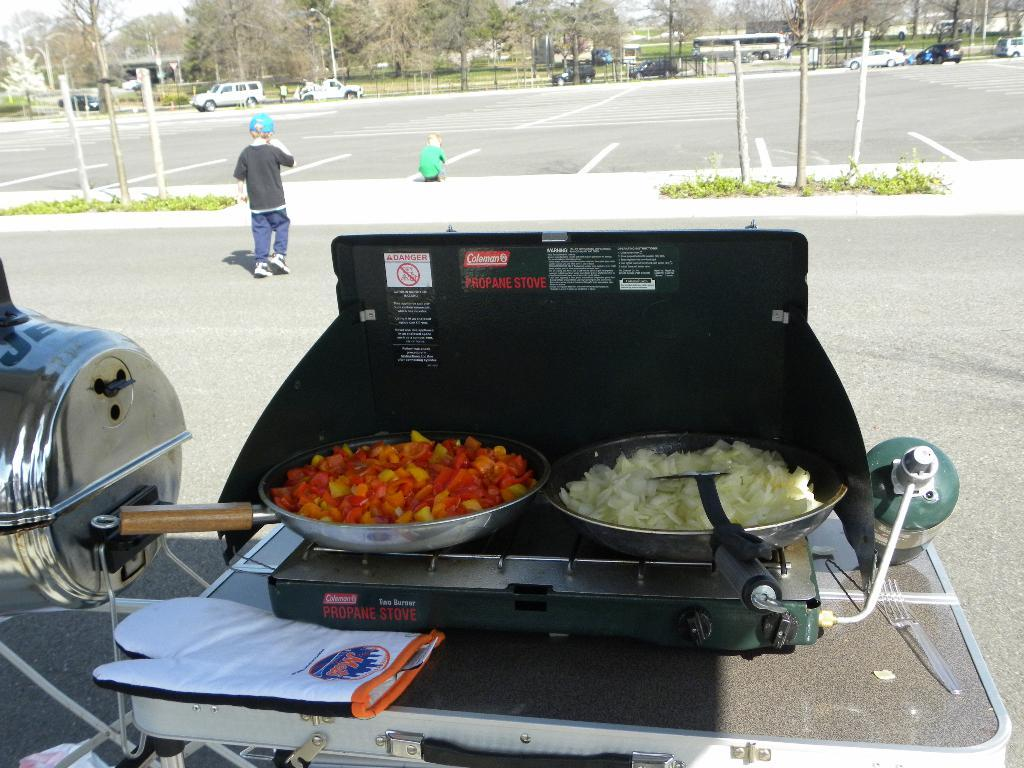<image>
Give a short and clear explanation of the subsequent image. a propane stove with a lot of food on it 